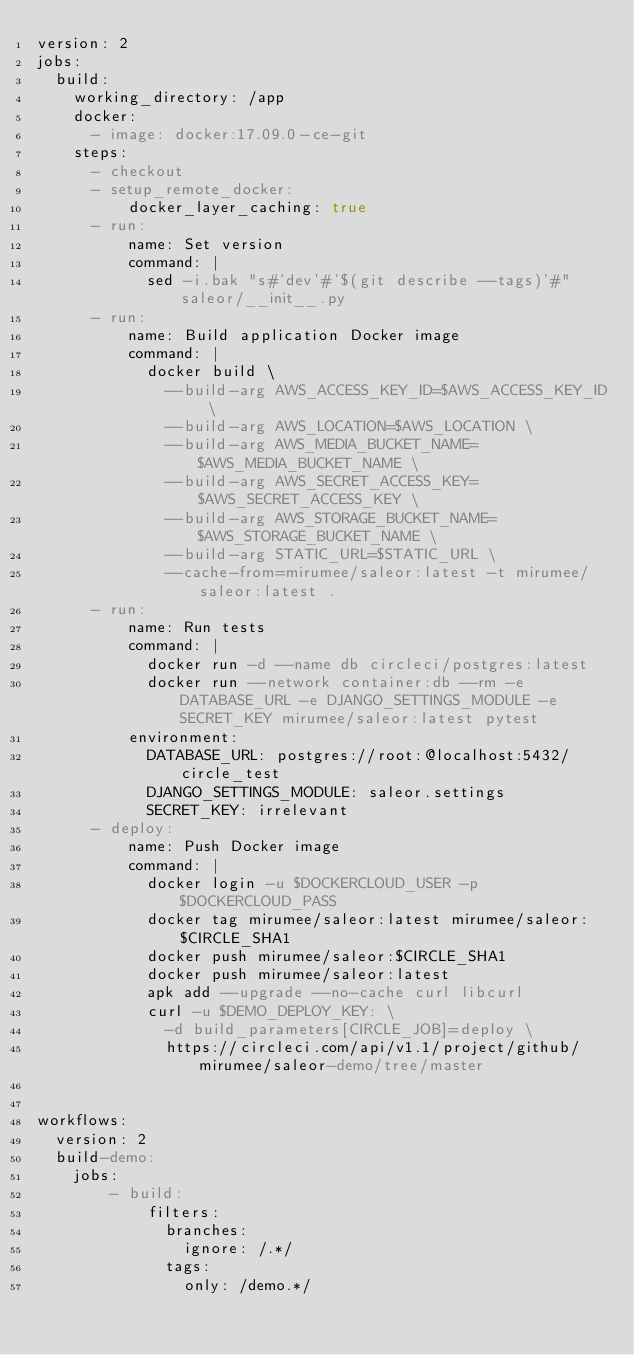<code> <loc_0><loc_0><loc_500><loc_500><_YAML_>version: 2
jobs:
  build:
    working_directory: /app
    docker:
      - image: docker:17.09.0-ce-git
    steps:
      - checkout
      - setup_remote_docker:
          docker_layer_caching: true
      - run:
          name: Set version
          command: |
            sed -i.bak "s#'dev'#'$(git describe --tags)'#" saleor/__init__.py
      - run:
          name: Build application Docker image
          command: |
            docker build \
              --build-arg AWS_ACCESS_KEY_ID=$AWS_ACCESS_KEY_ID \
              --build-arg AWS_LOCATION=$AWS_LOCATION \
              --build-arg AWS_MEDIA_BUCKET_NAME=$AWS_MEDIA_BUCKET_NAME \
              --build-arg AWS_SECRET_ACCESS_KEY=$AWS_SECRET_ACCESS_KEY \
              --build-arg AWS_STORAGE_BUCKET_NAME=$AWS_STORAGE_BUCKET_NAME \
              --build-arg STATIC_URL=$STATIC_URL \
              --cache-from=mirumee/saleor:latest -t mirumee/saleor:latest .
      - run:
          name: Run tests
          command: |
            docker run -d --name db circleci/postgres:latest
            docker run --network container:db --rm -e DATABASE_URL -e DJANGO_SETTINGS_MODULE -e SECRET_KEY mirumee/saleor:latest pytest
          environment:
            DATABASE_URL: postgres://root:@localhost:5432/circle_test
            DJANGO_SETTINGS_MODULE: saleor.settings
            SECRET_KEY: irrelevant
      - deploy:
          name: Push Docker image
          command: |
            docker login -u $DOCKERCLOUD_USER -p $DOCKERCLOUD_PASS
            docker tag mirumee/saleor:latest mirumee/saleor:$CIRCLE_SHA1
            docker push mirumee/saleor:$CIRCLE_SHA1
            docker push mirumee/saleor:latest
            apk add --upgrade --no-cache curl libcurl
            curl -u $DEMO_DEPLOY_KEY: \
              -d build_parameters[CIRCLE_JOB]=deploy \
              https://circleci.com/api/v1.1/project/github/mirumee/saleor-demo/tree/master


workflows:
  version: 2
  build-demo:
    jobs:
        - build:
            filters:
              branches:
                ignore: /.*/
              tags:
                only: /demo.*/
</code> 